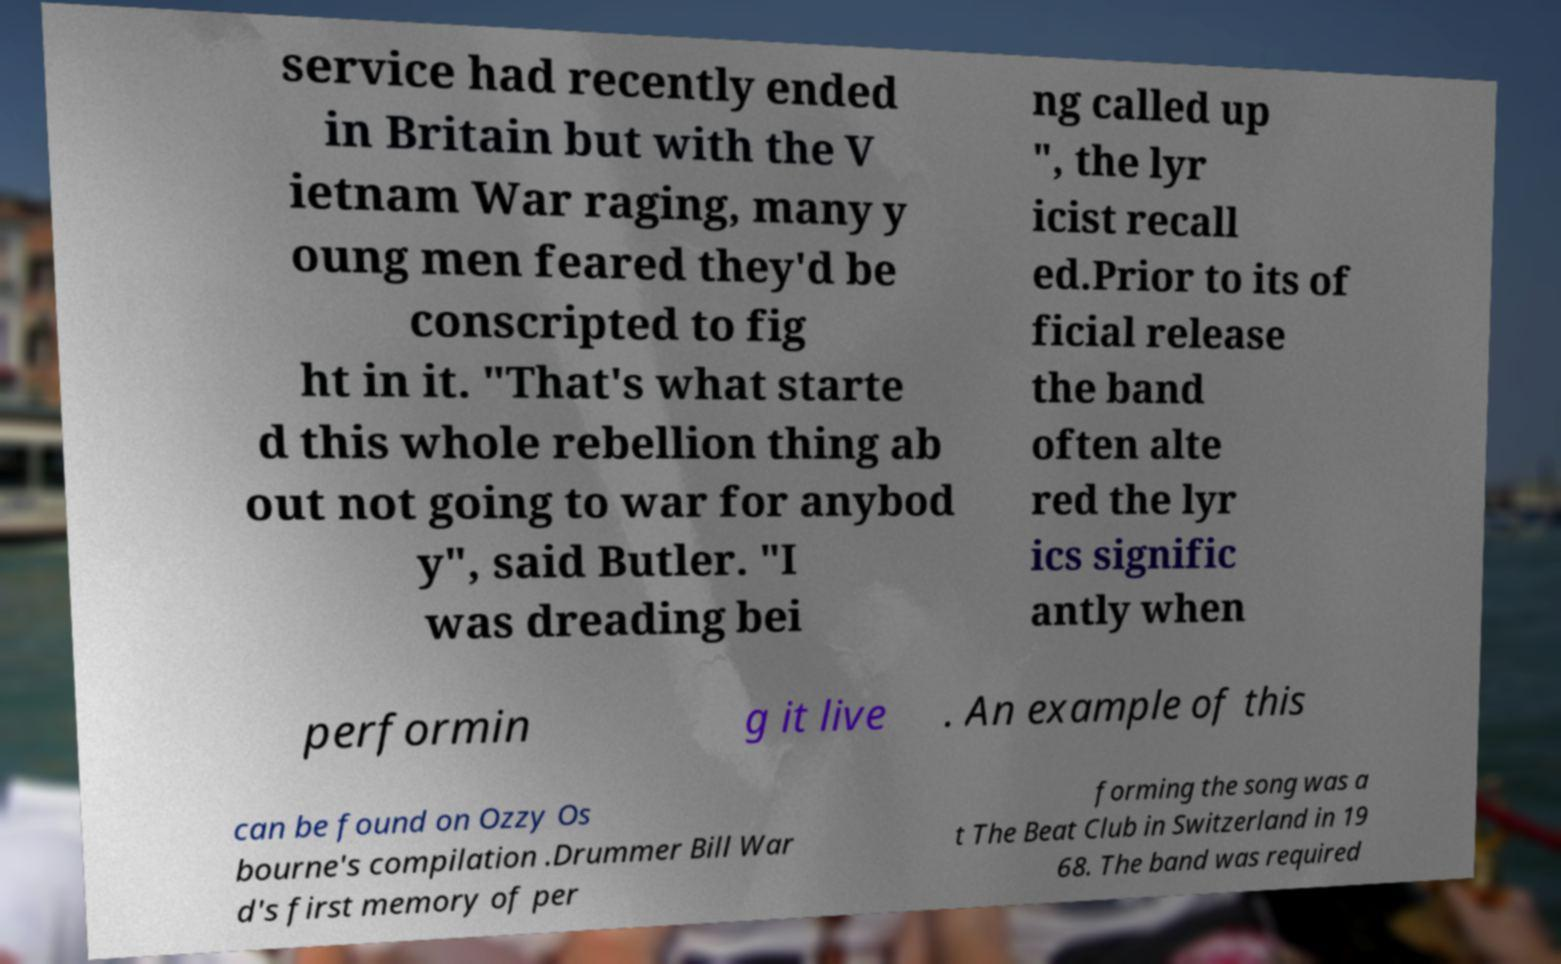There's text embedded in this image that I need extracted. Can you transcribe it verbatim? service had recently ended in Britain but with the V ietnam War raging, many y oung men feared they'd be conscripted to fig ht in it. "That's what starte d this whole rebellion thing ab out not going to war for anybod y", said Butler. "I was dreading bei ng called up ", the lyr icist recall ed.Prior to its of ficial release the band often alte red the lyr ics signific antly when performin g it live . An example of this can be found on Ozzy Os bourne's compilation .Drummer Bill War d's first memory of per forming the song was a t The Beat Club in Switzerland in 19 68. The band was required 